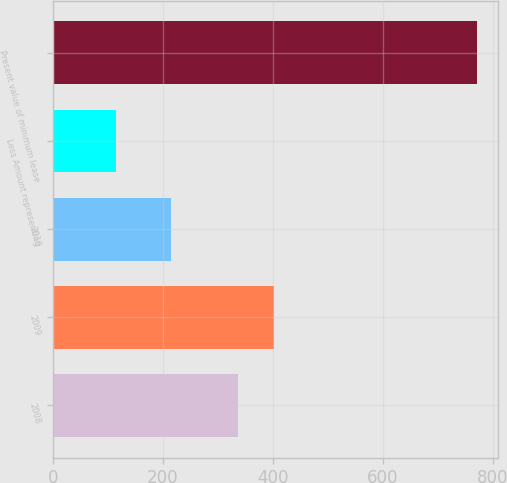Convert chart. <chart><loc_0><loc_0><loc_500><loc_500><bar_chart><fcel>2008<fcel>2009<fcel>2010<fcel>Less Amount representing<fcel>Present value of minimum lease<nl><fcel>336<fcel>401.6<fcel>214<fcel>115<fcel>771<nl></chart> 